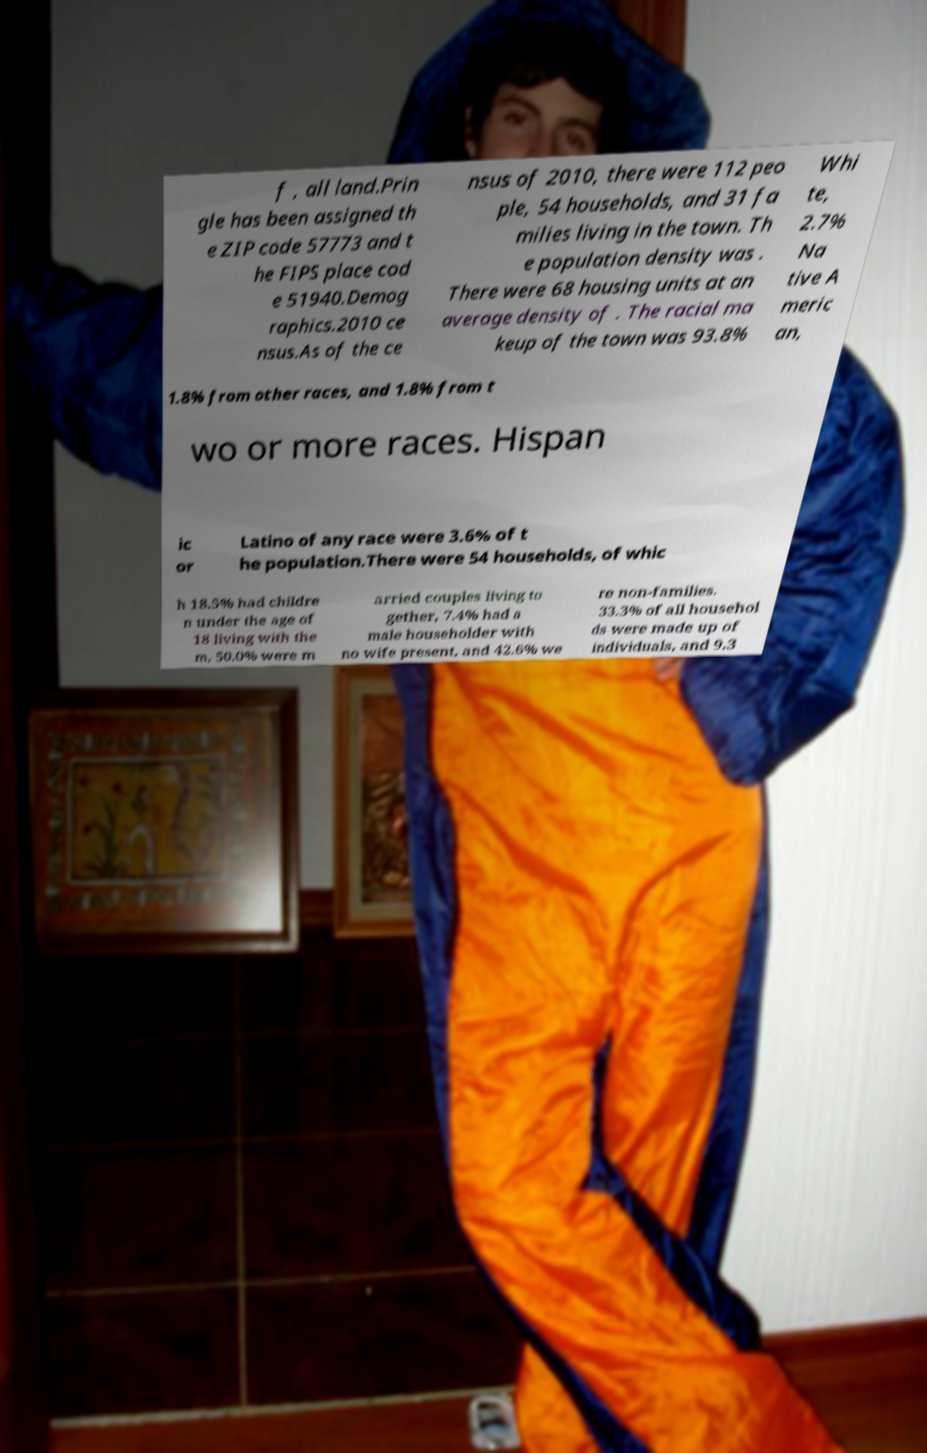For documentation purposes, I need the text within this image transcribed. Could you provide that? f , all land.Prin gle has been assigned th e ZIP code 57773 and t he FIPS place cod e 51940.Demog raphics.2010 ce nsus.As of the ce nsus of 2010, there were 112 peo ple, 54 households, and 31 fa milies living in the town. Th e population density was . There were 68 housing units at an average density of . The racial ma keup of the town was 93.8% Whi te, 2.7% Na tive A meric an, 1.8% from other races, and 1.8% from t wo or more races. Hispan ic or Latino of any race were 3.6% of t he population.There were 54 households, of whic h 18.5% had childre n under the age of 18 living with the m, 50.0% were m arried couples living to gether, 7.4% had a male householder with no wife present, and 42.6% we re non-families. 33.3% of all househol ds were made up of individuals, and 9.3 